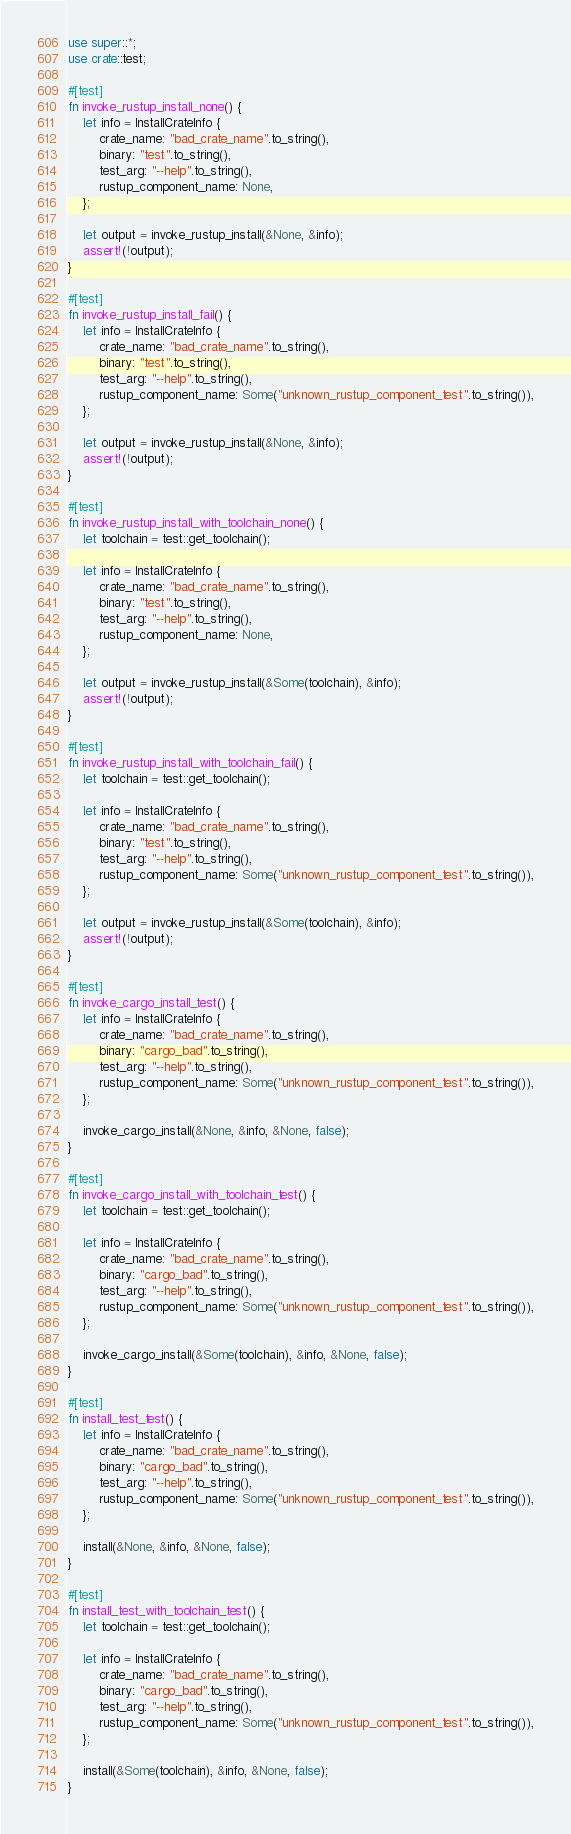<code> <loc_0><loc_0><loc_500><loc_500><_Rust_>use super::*;
use crate::test;

#[test]
fn invoke_rustup_install_none() {
    let info = InstallCrateInfo {
        crate_name: "bad_crate_name".to_string(),
        binary: "test".to_string(),
        test_arg: "--help".to_string(),
        rustup_component_name: None,
    };

    let output = invoke_rustup_install(&None, &info);
    assert!(!output);
}

#[test]
fn invoke_rustup_install_fail() {
    let info = InstallCrateInfo {
        crate_name: "bad_crate_name".to_string(),
        binary: "test".to_string(),
        test_arg: "--help".to_string(),
        rustup_component_name: Some("unknown_rustup_component_test".to_string()),
    };

    let output = invoke_rustup_install(&None, &info);
    assert!(!output);
}

#[test]
fn invoke_rustup_install_with_toolchain_none() {
    let toolchain = test::get_toolchain();

    let info = InstallCrateInfo {
        crate_name: "bad_crate_name".to_string(),
        binary: "test".to_string(),
        test_arg: "--help".to_string(),
        rustup_component_name: None,
    };

    let output = invoke_rustup_install(&Some(toolchain), &info);
    assert!(!output);
}

#[test]
fn invoke_rustup_install_with_toolchain_fail() {
    let toolchain = test::get_toolchain();

    let info = InstallCrateInfo {
        crate_name: "bad_crate_name".to_string(),
        binary: "test".to_string(),
        test_arg: "--help".to_string(),
        rustup_component_name: Some("unknown_rustup_component_test".to_string()),
    };

    let output = invoke_rustup_install(&Some(toolchain), &info);
    assert!(!output);
}

#[test]
fn invoke_cargo_install_test() {
    let info = InstallCrateInfo {
        crate_name: "bad_crate_name".to_string(),
        binary: "cargo_bad".to_string(),
        test_arg: "--help".to_string(),
        rustup_component_name: Some("unknown_rustup_component_test".to_string()),
    };

    invoke_cargo_install(&None, &info, &None, false);
}

#[test]
fn invoke_cargo_install_with_toolchain_test() {
    let toolchain = test::get_toolchain();

    let info = InstallCrateInfo {
        crate_name: "bad_crate_name".to_string(),
        binary: "cargo_bad".to_string(),
        test_arg: "--help".to_string(),
        rustup_component_name: Some("unknown_rustup_component_test".to_string()),
    };

    invoke_cargo_install(&Some(toolchain), &info, &None, false);
}

#[test]
fn install_test_test() {
    let info = InstallCrateInfo {
        crate_name: "bad_crate_name".to_string(),
        binary: "cargo_bad".to_string(),
        test_arg: "--help".to_string(),
        rustup_component_name: Some("unknown_rustup_component_test".to_string()),
    };

    install(&None, &info, &None, false);
}

#[test]
fn install_test_with_toolchain_test() {
    let toolchain = test::get_toolchain();

    let info = InstallCrateInfo {
        crate_name: "bad_crate_name".to_string(),
        binary: "cargo_bad".to_string(),
        test_arg: "--help".to_string(),
        rustup_component_name: Some("unknown_rustup_component_test".to_string()),
    };

    install(&Some(toolchain), &info, &None, false);
}
</code> 